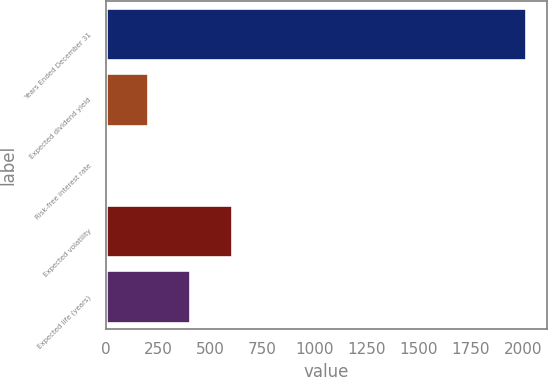Convert chart. <chart><loc_0><loc_0><loc_500><loc_500><bar_chart><fcel>Years Ended December 31<fcel>Expected dividend yield<fcel>Risk-free interest rate<fcel>Expected volatility<fcel>Expected life (years)<nl><fcel>2012<fcel>202.37<fcel>1.3<fcel>604.51<fcel>403.44<nl></chart> 